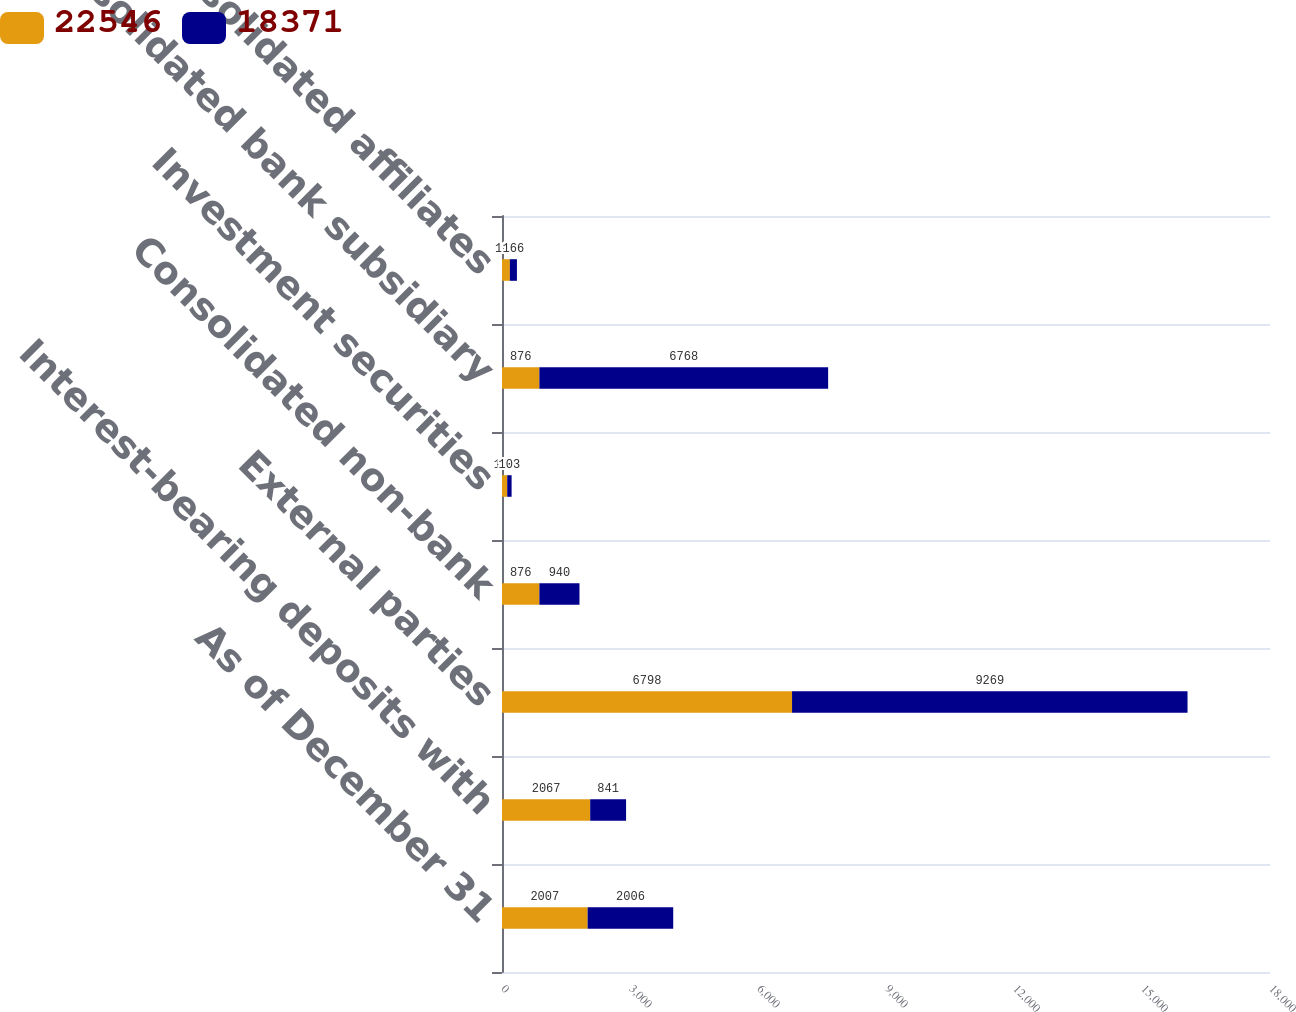Convert chart. <chart><loc_0><loc_0><loc_500><loc_500><stacked_bar_chart><ecel><fcel>As of December 31<fcel>Interest-bearing deposits with<fcel>External parties<fcel>Consolidated non-bank<fcel>Investment securities<fcel>Consolidated bank subsidiary<fcel>Unconsolidated affiliates<nl><fcel>22546<fcel>2007<fcel>2067<fcel>6798<fcel>876<fcel>122<fcel>876<fcel>184<nl><fcel>18371<fcel>2006<fcel>841<fcel>9269<fcel>940<fcel>103<fcel>6768<fcel>166<nl></chart> 